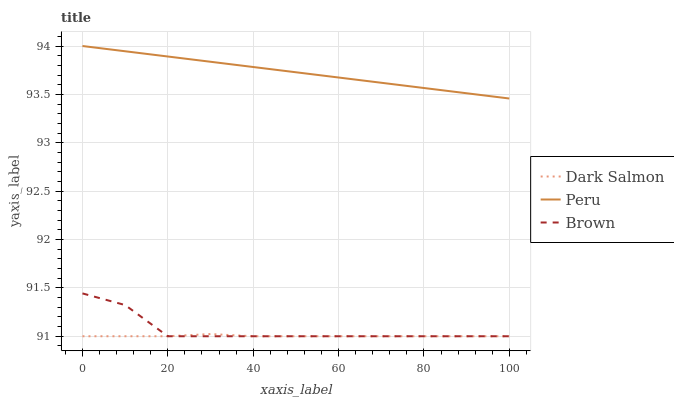Does Dark Salmon have the minimum area under the curve?
Answer yes or no. Yes. Does Peru have the maximum area under the curve?
Answer yes or no. Yes. Does Peru have the minimum area under the curve?
Answer yes or no. No. Does Dark Salmon have the maximum area under the curve?
Answer yes or no. No. Is Peru the smoothest?
Answer yes or no. Yes. Is Brown the roughest?
Answer yes or no. Yes. Is Dark Salmon the smoothest?
Answer yes or no. No. Is Dark Salmon the roughest?
Answer yes or no. No. Does Peru have the lowest value?
Answer yes or no. No. Does Peru have the highest value?
Answer yes or no. Yes. Does Dark Salmon have the highest value?
Answer yes or no. No. Is Dark Salmon less than Peru?
Answer yes or no. Yes. Is Peru greater than Brown?
Answer yes or no. Yes. Does Dark Salmon intersect Brown?
Answer yes or no. Yes. Is Dark Salmon less than Brown?
Answer yes or no. No. Is Dark Salmon greater than Brown?
Answer yes or no. No. Does Dark Salmon intersect Peru?
Answer yes or no. No. 